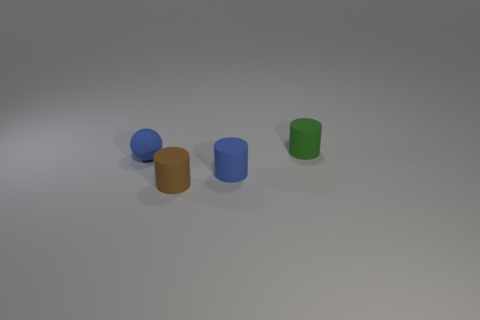There is a blue thing that is to the right of the brown matte thing; is it the same shape as the small green thing?
Provide a short and direct response. Yes. There is a matte cylinder behind the blue object that is behind the blue cylinder; how many small blue spheres are behind it?
Make the answer very short. 0. Are there any other things that have the same shape as the small green thing?
Offer a terse response. Yes. What number of objects are either matte things or tiny green matte objects?
Offer a terse response. 4. There is a green thing; is it the same shape as the blue thing on the left side of the brown matte cylinder?
Offer a very short reply. No. What is the shape of the tiny blue rubber object to the right of the brown matte cylinder?
Offer a terse response. Cylinder. Do the small brown thing and the tiny green thing have the same shape?
Make the answer very short. Yes. The blue rubber object that is the same shape as the small brown object is what size?
Offer a terse response. Small. Is the size of the blue matte thing on the left side of the brown thing the same as the blue cylinder?
Your answer should be compact. Yes. There is a matte thing that is on the left side of the blue matte cylinder and right of the small blue matte sphere; what size is it?
Your answer should be compact. Small. 